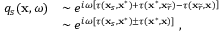Convert formula to latex. <formula><loc_0><loc_0><loc_500><loc_500>\begin{array} { r l } { q _ { s } ( x , \omega ) } & { \sim e ^ { i \omega \left [ \tau ( x _ { s } , x ^ { * } ) + \tau ( x ^ { * } , x _ { \widetilde { r } } ) - \tau ( x _ { \widetilde { r } } , x ) \right ] } } \\ & { \sim e ^ { i \omega \left [ \tau ( x _ { s } , x ^ { * } ) \pm \tau ( x ^ { * } , x ) \right ] } \, , } \end{array}</formula> 